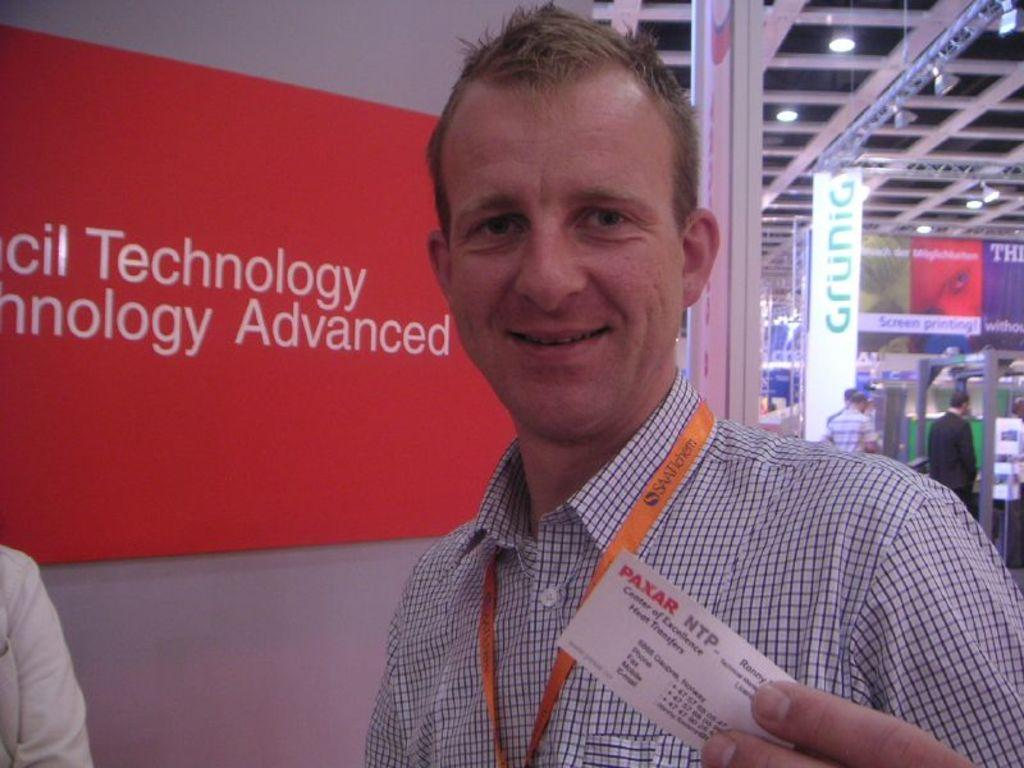What is the main subject of the image? There is a man standing in the image. Can you describe what the man is wearing? The man is wearing an orange color ID card and a shirt. What can be seen on the left side of the image? There is a red-colored board on the left side of the image. What is present at the top on the right side of the image? There are lights at the top on the right side of the image. How many spiders are crawling on the tree in the image? There is no tree or spiders present in the image. What type of toothpaste is the man using in the image? There is no toothpaste visible in the image. 